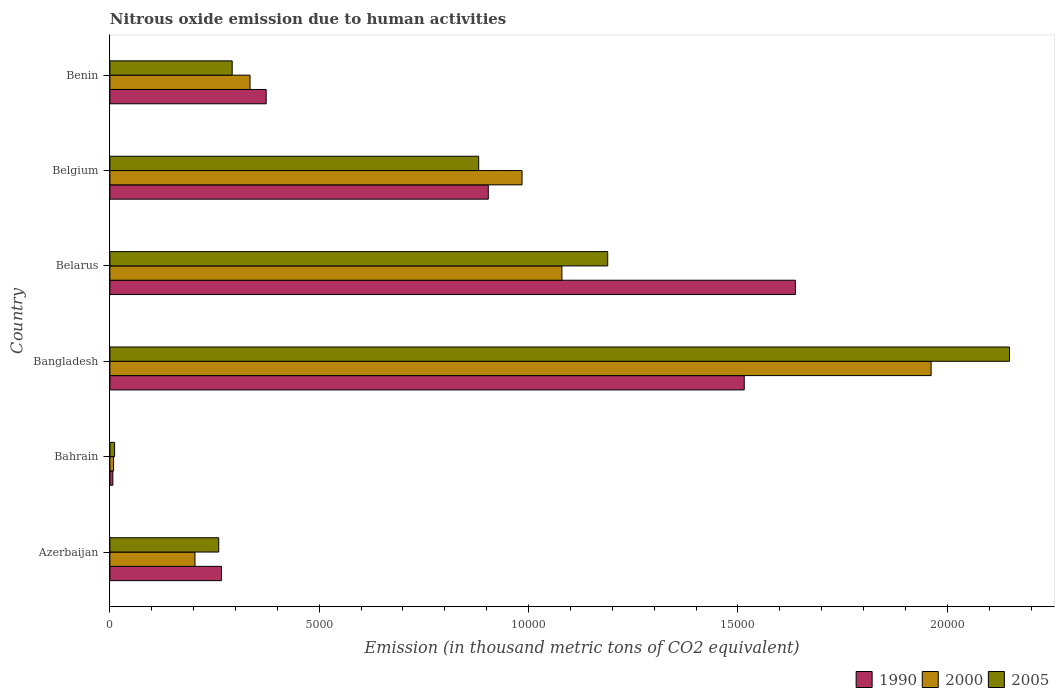How many groups of bars are there?
Offer a very short reply. 6. Are the number of bars per tick equal to the number of legend labels?
Your answer should be compact. Yes. What is the label of the 6th group of bars from the top?
Offer a terse response. Azerbaijan. What is the amount of nitrous oxide emitted in 2005 in Azerbaijan?
Make the answer very short. 2599.6. Across all countries, what is the maximum amount of nitrous oxide emitted in 2005?
Your response must be concise. 2.15e+04. Across all countries, what is the minimum amount of nitrous oxide emitted in 2005?
Provide a short and direct response. 112.9. In which country was the amount of nitrous oxide emitted in 2000 maximum?
Ensure brevity in your answer.  Bangladesh. In which country was the amount of nitrous oxide emitted in 2005 minimum?
Your answer should be compact. Bahrain. What is the total amount of nitrous oxide emitted in 2005 in the graph?
Provide a short and direct response. 4.78e+04. What is the difference between the amount of nitrous oxide emitted in 2005 in Bangladesh and that in Belgium?
Ensure brevity in your answer.  1.27e+04. What is the difference between the amount of nitrous oxide emitted in 2000 in Belarus and the amount of nitrous oxide emitted in 1990 in Azerbaijan?
Offer a terse response. 8130.1. What is the average amount of nitrous oxide emitted in 2000 per country?
Give a very brief answer. 7620.22. In how many countries, is the amount of nitrous oxide emitted in 1990 greater than 5000 thousand metric tons?
Your answer should be very brief. 3. What is the ratio of the amount of nitrous oxide emitted in 2005 in Bahrain to that in Bangladesh?
Provide a succinct answer. 0.01. Is the difference between the amount of nitrous oxide emitted in 2000 in Belarus and Belgium greater than the difference between the amount of nitrous oxide emitted in 1990 in Belarus and Belgium?
Offer a very short reply. No. What is the difference between the highest and the second highest amount of nitrous oxide emitted in 2000?
Provide a succinct answer. 8818.3. What is the difference between the highest and the lowest amount of nitrous oxide emitted in 1990?
Offer a terse response. 1.63e+04. In how many countries, is the amount of nitrous oxide emitted in 2000 greater than the average amount of nitrous oxide emitted in 2000 taken over all countries?
Provide a short and direct response. 3. How many bars are there?
Your answer should be very brief. 18. Are all the bars in the graph horizontal?
Ensure brevity in your answer.  Yes. Are the values on the major ticks of X-axis written in scientific E-notation?
Provide a succinct answer. No. Does the graph contain grids?
Give a very brief answer. No. How are the legend labels stacked?
Offer a very short reply. Horizontal. What is the title of the graph?
Offer a terse response. Nitrous oxide emission due to human activities. What is the label or title of the X-axis?
Offer a terse response. Emission (in thousand metric tons of CO2 equivalent). What is the Emission (in thousand metric tons of CO2 equivalent) in 1990 in Azerbaijan?
Offer a terse response. 2665.8. What is the Emission (in thousand metric tons of CO2 equivalent) in 2000 in Azerbaijan?
Your answer should be compact. 2031.7. What is the Emission (in thousand metric tons of CO2 equivalent) in 2005 in Azerbaijan?
Provide a succinct answer. 2599.6. What is the Emission (in thousand metric tons of CO2 equivalent) in 1990 in Bahrain?
Your answer should be very brief. 70.2. What is the Emission (in thousand metric tons of CO2 equivalent) in 2000 in Bahrain?
Your answer should be compact. 88.2. What is the Emission (in thousand metric tons of CO2 equivalent) in 2005 in Bahrain?
Ensure brevity in your answer.  112.9. What is the Emission (in thousand metric tons of CO2 equivalent) in 1990 in Bangladesh?
Give a very brief answer. 1.52e+04. What is the Emission (in thousand metric tons of CO2 equivalent) in 2000 in Bangladesh?
Your response must be concise. 1.96e+04. What is the Emission (in thousand metric tons of CO2 equivalent) of 2005 in Bangladesh?
Give a very brief answer. 2.15e+04. What is the Emission (in thousand metric tons of CO2 equivalent) of 1990 in Belarus?
Provide a short and direct response. 1.64e+04. What is the Emission (in thousand metric tons of CO2 equivalent) in 2000 in Belarus?
Provide a succinct answer. 1.08e+04. What is the Emission (in thousand metric tons of CO2 equivalent) in 2005 in Belarus?
Your answer should be very brief. 1.19e+04. What is the Emission (in thousand metric tons of CO2 equivalent) in 1990 in Belgium?
Your answer should be very brief. 9037.7. What is the Emission (in thousand metric tons of CO2 equivalent) in 2000 in Belgium?
Your answer should be very brief. 9844.1. What is the Emission (in thousand metric tons of CO2 equivalent) in 2005 in Belgium?
Your answer should be very brief. 8808.6. What is the Emission (in thousand metric tons of CO2 equivalent) of 1990 in Benin?
Your response must be concise. 3732.5. What is the Emission (in thousand metric tons of CO2 equivalent) in 2000 in Benin?
Offer a terse response. 3347.2. What is the Emission (in thousand metric tons of CO2 equivalent) in 2005 in Benin?
Provide a succinct answer. 2920.4. Across all countries, what is the maximum Emission (in thousand metric tons of CO2 equivalent) of 1990?
Keep it short and to the point. 1.64e+04. Across all countries, what is the maximum Emission (in thousand metric tons of CO2 equivalent) in 2000?
Make the answer very short. 1.96e+04. Across all countries, what is the maximum Emission (in thousand metric tons of CO2 equivalent) of 2005?
Offer a very short reply. 2.15e+04. Across all countries, what is the minimum Emission (in thousand metric tons of CO2 equivalent) of 1990?
Your answer should be compact. 70.2. Across all countries, what is the minimum Emission (in thousand metric tons of CO2 equivalent) of 2000?
Ensure brevity in your answer.  88.2. Across all countries, what is the minimum Emission (in thousand metric tons of CO2 equivalent) of 2005?
Your answer should be compact. 112.9. What is the total Emission (in thousand metric tons of CO2 equivalent) in 1990 in the graph?
Provide a succinct answer. 4.70e+04. What is the total Emission (in thousand metric tons of CO2 equivalent) in 2000 in the graph?
Your response must be concise. 4.57e+04. What is the total Emission (in thousand metric tons of CO2 equivalent) of 2005 in the graph?
Provide a succinct answer. 4.78e+04. What is the difference between the Emission (in thousand metric tons of CO2 equivalent) of 1990 in Azerbaijan and that in Bahrain?
Offer a very short reply. 2595.6. What is the difference between the Emission (in thousand metric tons of CO2 equivalent) of 2000 in Azerbaijan and that in Bahrain?
Keep it short and to the point. 1943.5. What is the difference between the Emission (in thousand metric tons of CO2 equivalent) in 2005 in Azerbaijan and that in Bahrain?
Ensure brevity in your answer.  2486.7. What is the difference between the Emission (in thousand metric tons of CO2 equivalent) of 1990 in Azerbaijan and that in Bangladesh?
Provide a short and direct response. -1.25e+04. What is the difference between the Emission (in thousand metric tons of CO2 equivalent) in 2000 in Azerbaijan and that in Bangladesh?
Make the answer very short. -1.76e+04. What is the difference between the Emission (in thousand metric tons of CO2 equivalent) of 2005 in Azerbaijan and that in Bangladesh?
Keep it short and to the point. -1.89e+04. What is the difference between the Emission (in thousand metric tons of CO2 equivalent) in 1990 in Azerbaijan and that in Belarus?
Provide a succinct answer. -1.37e+04. What is the difference between the Emission (in thousand metric tons of CO2 equivalent) of 2000 in Azerbaijan and that in Belarus?
Make the answer very short. -8764.2. What is the difference between the Emission (in thousand metric tons of CO2 equivalent) in 2005 in Azerbaijan and that in Belarus?
Offer a terse response. -9290.6. What is the difference between the Emission (in thousand metric tons of CO2 equivalent) in 1990 in Azerbaijan and that in Belgium?
Offer a very short reply. -6371.9. What is the difference between the Emission (in thousand metric tons of CO2 equivalent) of 2000 in Azerbaijan and that in Belgium?
Keep it short and to the point. -7812.4. What is the difference between the Emission (in thousand metric tons of CO2 equivalent) in 2005 in Azerbaijan and that in Belgium?
Your response must be concise. -6209. What is the difference between the Emission (in thousand metric tons of CO2 equivalent) in 1990 in Azerbaijan and that in Benin?
Make the answer very short. -1066.7. What is the difference between the Emission (in thousand metric tons of CO2 equivalent) in 2000 in Azerbaijan and that in Benin?
Ensure brevity in your answer.  -1315.5. What is the difference between the Emission (in thousand metric tons of CO2 equivalent) in 2005 in Azerbaijan and that in Benin?
Ensure brevity in your answer.  -320.8. What is the difference between the Emission (in thousand metric tons of CO2 equivalent) of 1990 in Bahrain and that in Bangladesh?
Give a very brief answer. -1.51e+04. What is the difference between the Emission (in thousand metric tons of CO2 equivalent) in 2000 in Bahrain and that in Bangladesh?
Give a very brief answer. -1.95e+04. What is the difference between the Emission (in thousand metric tons of CO2 equivalent) in 2005 in Bahrain and that in Bangladesh?
Make the answer very short. -2.14e+04. What is the difference between the Emission (in thousand metric tons of CO2 equivalent) of 1990 in Bahrain and that in Belarus?
Keep it short and to the point. -1.63e+04. What is the difference between the Emission (in thousand metric tons of CO2 equivalent) of 2000 in Bahrain and that in Belarus?
Your response must be concise. -1.07e+04. What is the difference between the Emission (in thousand metric tons of CO2 equivalent) of 2005 in Bahrain and that in Belarus?
Keep it short and to the point. -1.18e+04. What is the difference between the Emission (in thousand metric tons of CO2 equivalent) in 1990 in Bahrain and that in Belgium?
Your answer should be compact. -8967.5. What is the difference between the Emission (in thousand metric tons of CO2 equivalent) of 2000 in Bahrain and that in Belgium?
Offer a terse response. -9755.9. What is the difference between the Emission (in thousand metric tons of CO2 equivalent) in 2005 in Bahrain and that in Belgium?
Your answer should be compact. -8695.7. What is the difference between the Emission (in thousand metric tons of CO2 equivalent) in 1990 in Bahrain and that in Benin?
Make the answer very short. -3662.3. What is the difference between the Emission (in thousand metric tons of CO2 equivalent) in 2000 in Bahrain and that in Benin?
Offer a very short reply. -3259. What is the difference between the Emission (in thousand metric tons of CO2 equivalent) in 2005 in Bahrain and that in Benin?
Your answer should be very brief. -2807.5. What is the difference between the Emission (in thousand metric tons of CO2 equivalent) in 1990 in Bangladesh and that in Belarus?
Give a very brief answer. -1221.7. What is the difference between the Emission (in thousand metric tons of CO2 equivalent) of 2000 in Bangladesh and that in Belarus?
Give a very brief answer. 8818.3. What is the difference between the Emission (in thousand metric tons of CO2 equivalent) of 2005 in Bangladesh and that in Belarus?
Provide a succinct answer. 9596.5. What is the difference between the Emission (in thousand metric tons of CO2 equivalent) of 1990 in Bangladesh and that in Belgium?
Keep it short and to the point. 6112.9. What is the difference between the Emission (in thousand metric tons of CO2 equivalent) of 2000 in Bangladesh and that in Belgium?
Offer a terse response. 9770.1. What is the difference between the Emission (in thousand metric tons of CO2 equivalent) in 2005 in Bangladesh and that in Belgium?
Your response must be concise. 1.27e+04. What is the difference between the Emission (in thousand metric tons of CO2 equivalent) in 1990 in Bangladesh and that in Benin?
Your answer should be compact. 1.14e+04. What is the difference between the Emission (in thousand metric tons of CO2 equivalent) in 2000 in Bangladesh and that in Benin?
Provide a succinct answer. 1.63e+04. What is the difference between the Emission (in thousand metric tons of CO2 equivalent) in 2005 in Bangladesh and that in Benin?
Give a very brief answer. 1.86e+04. What is the difference between the Emission (in thousand metric tons of CO2 equivalent) of 1990 in Belarus and that in Belgium?
Ensure brevity in your answer.  7334.6. What is the difference between the Emission (in thousand metric tons of CO2 equivalent) of 2000 in Belarus and that in Belgium?
Ensure brevity in your answer.  951.8. What is the difference between the Emission (in thousand metric tons of CO2 equivalent) in 2005 in Belarus and that in Belgium?
Make the answer very short. 3081.6. What is the difference between the Emission (in thousand metric tons of CO2 equivalent) of 1990 in Belarus and that in Benin?
Offer a terse response. 1.26e+04. What is the difference between the Emission (in thousand metric tons of CO2 equivalent) in 2000 in Belarus and that in Benin?
Make the answer very short. 7448.7. What is the difference between the Emission (in thousand metric tons of CO2 equivalent) of 2005 in Belarus and that in Benin?
Keep it short and to the point. 8969.8. What is the difference between the Emission (in thousand metric tons of CO2 equivalent) in 1990 in Belgium and that in Benin?
Give a very brief answer. 5305.2. What is the difference between the Emission (in thousand metric tons of CO2 equivalent) of 2000 in Belgium and that in Benin?
Keep it short and to the point. 6496.9. What is the difference between the Emission (in thousand metric tons of CO2 equivalent) in 2005 in Belgium and that in Benin?
Ensure brevity in your answer.  5888.2. What is the difference between the Emission (in thousand metric tons of CO2 equivalent) of 1990 in Azerbaijan and the Emission (in thousand metric tons of CO2 equivalent) of 2000 in Bahrain?
Offer a terse response. 2577.6. What is the difference between the Emission (in thousand metric tons of CO2 equivalent) of 1990 in Azerbaijan and the Emission (in thousand metric tons of CO2 equivalent) of 2005 in Bahrain?
Your answer should be very brief. 2552.9. What is the difference between the Emission (in thousand metric tons of CO2 equivalent) in 2000 in Azerbaijan and the Emission (in thousand metric tons of CO2 equivalent) in 2005 in Bahrain?
Provide a short and direct response. 1918.8. What is the difference between the Emission (in thousand metric tons of CO2 equivalent) in 1990 in Azerbaijan and the Emission (in thousand metric tons of CO2 equivalent) in 2000 in Bangladesh?
Offer a terse response. -1.69e+04. What is the difference between the Emission (in thousand metric tons of CO2 equivalent) of 1990 in Azerbaijan and the Emission (in thousand metric tons of CO2 equivalent) of 2005 in Bangladesh?
Your response must be concise. -1.88e+04. What is the difference between the Emission (in thousand metric tons of CO2 equivalent) of 2000 in Azerbaijan and the Emission (in thousand metric tons of CO2 equivalent) of 2005 in Bangladesh?
Give a very brief answer. -1.95e+04. What is the difference between the Emission (in thousand metric tons of CO2 equivalent) in 1990 in Azerbaijan and the Emission (in thousand metric tons of CO2 equivalent) in 2000 in Belarus?
Provide a short and direct response. -8130.1. What is the difference between the Emission (in thousand metric tons of CO2 equivalent) of 1990 in Azerbaijan and the Emission (in thousand metric tons of CO2 equivalent) of 2005 in Belarus?
Your answer should be compact. -9224.4. What is the difference between the Emission (in thousand metric tons of CO2 equivalent) of 2000 in Azerbaijan and the Emission (in thousand metric tons of CO2 equivalent) of 2005 in Belarus?
Provide a short and direct response. -9858.5. What is the difference between the Emission (in thousand metric tons of CO2 equivalent) in 1990 in Azerbaijan and the Emission (in thousand metric tons of CO2 equivalent) in 2000 in Belgium?
Offer a very short reply. -7178.3. What is the difference between the Emission (in thousand metric tons of CO2 equivalent) in 1990 in Azerbaijan and the Emission (in thousand metric tons of CO2 equivalent) in 2005 in Belgium?
Your answer should be very brief. -6142.8. What is the difference between the Emission (in thousand metric tons of CO2 equivalent) of 2000 in Azerbaijan and the Emission (in thousand metric tons of CO2 equivalent) of 2005 in Belgium?
Ensure brevity in your answer.  -6776.9. What is the difference between the Emission (in thousand metric tons of CO2 equivalent) in 1990 in Azerbaijan and the Emission (in thousand metric tons of CO2 equivalent) in 2000 in Benin?
Your answer should be very brief. -681.4. What is the difference between the Emission (in thousand metric tons of CO2 equivalent) in 1990 in Azerbaijan and the Emission (in thousand metric tons of CO2 equivalent) in 2005 in Benin?
Provide a succinct answer. -254.6. What is the difference between the Emission (in thousand metric tons of CO2 equivalent) in 2000 in Azerbaijan and the Emission (in thousand metric tons of CO2 equivalent) in 2005 in Benin?
Provide a succinct answer. -888.7. What is the difference between the Emission (in thousand metric tons of CO2 equivalent) of 1990 in Bahrain and the Emission (in thousand metric tons of CO2 equivalent) of 2000 in Bangladesh?
Offer a terse response. -1.95e+04. What is the difference between the Emission (in thousand metric tons of CO2 equivalent) of 1990 in Bahrain and the Emission (in thousand metric tons of CO2 equivalent) of 2005 in Bangladesh?
Ensure brevity in your answer.  -2.14e+04. What is the difference between the Emission (in thousand metric tons of CO2 equivalent) in 2000 in Bahrain and the Emission (in thousand metric tons of CO2 equivalent) in 2005 in Bangladesh?
Offer a very short reply. -2.14e+04. What is the difference between the Emission (in thousand metric tons of CO2 equivalent) of 1990 in Bahrain and the Emission (in thousand metric tons of CO2 equivalent) of 2000 in Belarus?
Offer a terse response. -1.07e+04. What is the difference between the Emission (in thousand metric tons of CO2 equivalent) in 1990 in Bahrain and the Emission (in thousand metric tons of CO2 equivalent) in 2005 in Belarus?
Give a very brief answer. -1.18e+04. What is the difference between the Emission (in thousand metric tons of CO2 equivalent) of 2000 in Bahrain and the Emission (in thousand metric tons of CO2 equivalent) of 2005 in Belarus?
Make the answer very short. -1.18e+04. What is the difference between the Emission (in thousand metric tons of CO2 equivalent) of 1990 in Bahrain and the Emission (in thousand metric tons of CO2 equivalent) of 2000 in Belgium?
Your response must be concise. -9773.9. What is the difference between the Emission (in thousand metric tons of CO2 equivalent) in 1990 in Bahrain and the Emission (in thousand metric tons of CO2 equivalent) in 2005 in Belgium?
Ensure brevity in your answer.  -8738.4. What is the difference between the Emission (in thousand metric tons of CO2 equivalent) in 2000 in Bahrain and the Emission (in thousand metric tons of CO2 equivalent) in 2005 in Belgium?
Your answer should be very brief. -8720.4. What is the difference between the Emission (in thousand metric tons of CO2 equivalent) in 1990 in Bahrain and the Emission (in thousand metric tons of CO2 equivalent) in 2000 in Benin?
Make the answer very short. -3277. What is the difference between the Emission (in thousand metric tons of CO2 equivalent) in 1990 in Bahrain and the Emission (in thousand metric tons of CO2 equivalent) in 2005 in Benin?
Offer a very short reply. -2850.2. What is the difference between the Emission (in thousand metric tons of CO2 equivalent) of 2000 in Bahrain and the Emission (in thousand metric tons of CO2 equivalent) of 2005 in Benin?
Offer a very short reply. -2832.2. What is the difference between the Emission (in thousand metric tons of CO2 equivalent) in 1990 in Bangladesh and the Emission (in thousand metric tons of CO2 equivalent) in 2000 in Belarus?
Provide a short and direct response. 4354.7. What is the difference between the Emission (in thousand metric tons of CO2 equivalent) in 1990 in Bangladesh and the Emission (in thousand metric tons of CO2 equivalent) in 2005 in Belarus?
Your answer should be compact. 3260.4. What is the difference between the Emission (in thousand metric tons of CO2 equivalent) of 2000 in Bangladesh and the Emission (in thousand metric tons of CO2 equivalent) of 2005 in Belarus?
Offer a terse response. 7724. What is the difference between the Emission (in thousand metric tons of CO2 equivalent) in 1990 in Bangladesh and the Emission (in thousand metric tons of CO2 equivalent) in 2000 in Belgium?
Your answer should be compact. 5306.5. What is the difference between the Emission (in thousand metric tons of CO2 equivalent) of 1990 in Bangladesh and the Emission (in thousand metric tons of CO2 equivalent) of 2005 in Belgium?
Make the answer very short. 6342. What is the difference between the Emission (in thousand metric tons of CO2 equivalent) in 2000 in Bangladesh and the Emission (in thousand metric tons of CO2 equivalent) in 2005 in Belgium?
Keep it short and to the point. 1.08e+04. What is the difference between the Emission (in thousand metric tons of CO2 equivalent) of 1990 in Bangladesh and the Emission (in thousand metric tons of CO2 equivalent) of 2000 in Benin?
Your response must be concise. 1.18e+04. What is the difference between the Emission (in thousand metric tons of CO2 equivalent) of 1990 in Bangladesh and the Emission (in thousand metric tons of CO2 equivalent) of 2005 in Benin?
Offer a terse response. 1.22e+04. What is the difference between the Emission (in thousand metric tons of CO2 equivalent) in 2000 in Bangladesh and the Emission (in thousand metric tons of CO2 equivalent) in 2005 in Benin?
Make the answer very short. 1.67e+04. What is the difference between the Emission (in thousand metric tons of CO2 equivalent) of 1990 in Belarus and the Emission (in thousand metric tons of CO2 equivalent) of 2000 in Belgium?
Ensure brevity in your answer.  6528.2. What is the difference between the Emission (in thousand metric tons of CO2 equivalent) in 1990 in Belarus and the Emission (in thousand metric tons of CO2 equivalent) in 2005 in Belgium?
Keep it short and to the point. 7563.7. What is the difference between the Emission (in thousand metric tons of CO2 equivalent) in 2000 in Belarus and the Emission (in thousand metric tons of CO2 equivalent) in 2005 in Belgium?
Your answer should be compact. 1987.3. What is the difference between the Emission (in thousand metric tons of CO2 equivalent) in 1990 in Belarus and the Emission (in thousand metric tons of CO2 equivalent) in 2000 in Benin?
Provide a succinct answer. 1.30e+04. What is the difference between the Emission (in thousand metric tons of CO2 equivalent) in 1990 in Belarus and the Emission (in thousand metric tons of CO2 equivalent) in 2005 in Benin?
Provide a succinct answer. 1.35e+04. What is the difference between the Emission (in thousand metric tons of CO2 equivalent) in 2000 in Belarus and the Emission (in thousand metric tons of CO2 equivalent) in 2005 in Benin?
Make the answer very short. 7875.5. What is the difference between the Emission (in thousand metric tons of CO2 equivalent) in 1990 in Belgium and the Emission (in thousand metric tons of CO2 equivalent) in 2000 in Benin?
Offer a very short reply. 5690.5. What is the difference between the Emission (in thousand metric tons of CO2 equivalent) of 1990 in Belgium and the Emission (in thousand metric tons of CO2 equivalent) of 2005 in Benin?
Provide a short and direct response. 6117.3. What is the difference between the Emission (in thousand metric tons of CO2 equivalent) of 2000 in Belgium and the Emission (in thousand metric tons of CO2 equivalent) of 2005 in Benin?
Keep it short and to the point. 6923.7. What is the average Emission (in thousand metric tons of CO2 equivalent) of 1990 per country?
Offer a very short reply. 7838.18. What is the average Emission (in thousand metric tons of CO2 equivalent) of 2000 per country?
Keep it short and to the point. 7620.22. What is the average Emission (in thousand metric tons of CO2 equivalent) of 2005 per country?
Provide a short and direct response. 7969.73. What is the difference between the Emission (in thousand metric tons of CO2 equivalent) in 1990 and Emission (in thousand metric tons of CO2 equivalent) in 2000 in Azerbaijan?
Offer a very short reply. 634.1. What is the difference between the Emission (in thousand metric tons of CO2 equivalent) of 1990 and Emission (in thousand metric tons of CO2 equivalent) of 2005 in Azerbaijan?
Your answer should be compact. 66.2. What is the difference between the Emission (in thousand metric tons of CO2 equivalent) in 2000 and Emission (in thousand metric tons of CO2 equivalent) in 2005 in Azerbaijan?
Offer a very short reply. -567.9. What is the difference between the Emission (in thousand metric tons of CO2 equivalent) of 1990 and Emission (in thousand metric tons of CO2 equivalent) of 2005 in Bahrain?
Offer a very short reply. -42.7. What is the difference between the Emission (in thousand metric tons of CO2 equivalent) of 2000 and Emission (in thousand metric tons of CO2 equivalent) of 2005 in Bahrain?
Your answer should be very brief. -24.7. What is the difference between the Emission (in thousand metric tons of CO2 equivalent) of 1990 and Emission (in thousand metric tons of CO2 equivalent) of 2000 in Bangladesh?
Make the answer very short. -4463.6. What is the difference between the Emission (in thousand metric tons of CO2 equivalent) of 1990 and Emission (in thousand metric tons of CO2 equivalent) of 2005 in Bangladesh?
Your answer should be compact. -6336.1. What is the difference between the Emission (in thousand metric tons of CO2 equivalent) of 2000 and Emission (in thousand metric tons of CO2 equivalent) of 2005 in Bangladesh?
Keep it short and to the point. -1872.5. What is the difference between the Emission (in thousand metric tons of CO2 equivalent) in 1990 and Emission (in thousand metric tons of CO2 equivalent) in 2000 in Belarus?
Ensure brevity in your answer.  5576.4. What is the difference between the Emission (in thousand metric tons of CO2 equivalent) in 1990 and Emission (in thousand metric tons of CO2 equivalent) in 2005 in Belarus?
Your answer should be compact. 4482.1. What is the difference between the Emission (in thousand metric tons of CO2 equivalent) in 2000 and Emission (in thousand metric tons of CO2 equivalent) in 2005 in Belarus?
Keep it short and to the point. -1094.3. What is the difference between the Emission (in thousand metric tons of CO2 equivalent) of 1990 and Emission (in thousand metric tons of CO2 equivalent) of 2000 in Belgium?
Make the answer very short. -806.4. What is the difference between the Emission (in thousand metric tons of CO2 equivalent) of 1990 and Emission (in thousand metric tons of CO2 equivalent) of 2005 in Belgium?
Ensure brevity in your answer.  229.1. What is the difference between the Emission (in thousand metric tons of CO2 equivalent) of 2000 and Emission (in thousand metric tons of CO2 equivalent) of 2005 in Belgium?
Your answer should be compact. 1035.5. What is the difference between the Emission (in thousand metric tons of CO2 equivalent) of 1990 and Emission (in thousand metric tons of CO2 equivalent) of 2000 in Benin?
Your answer should be compact. 385.3. What is the difference between the Emission (in thousand metric tons of CO2 equivalent) in 1990 and Emission (in thousand metric tons of CO2 equivalent) in 2005 in Benin?
Give a very brief answer. 812.1. What is the difference between the Emission (in thousand metric tons of CO2 equivalent) of 2000 and Emission (in thousand metric tons of CO2 equivalent) of 2005 in Benin?
Your answer should be compact. 426.8. What is the ratio of the Emission (in thousand metric tons of CO2 equivalent) of 1990 in Azerbaijan to that in Bahrain?
Make the answer very short. 37.97. What is the ratio of the Emission (in thousand metric tons of CO2 equivalent) in 2000 in Azerbaijan to that in Bahrain?
Your response must be concise. 23.04. What is the ratio of the Emission (in thousand metric tons of CO2 equivalent) in 2005 in Azerbaijan to that in Bahrain?
Provide a short and direct response. 23.03. What is the ratio of the Emission (in thousand metric tons of CO2 equivalent) of 1990 in Azerbaijan to that in Bangladesh?
Provide a succinct answer. 0.18. What is the ratio of the Emission (in thousand metric tons of CO2 equivalent) in 2000 in Azerbaijan to that in Bangladesh?
Keep it short and to the point. 0.1. What is the ratio of the Emission (in thousand metric tons of CO2 equivalent) in 2005 in Azerbaijan to that in Bangladesh?
Provide a succinct answer. 0.12. What is the ratio of the Emission (in thousand metric tons of CO2 equivalent) of 1990 in Azerbaijan to that in Belarus?
Your answer should be very brief. 0.16. What is the ratio of the Emission (in thousand metric tons of CO2 equivalent) of 2000 in Azerbaijan to that in Belarus?
Make the answer very short. 0.19. What is the ratio of the Emission (in thousand metric tons of CO2 equivalent) of 2005 in Azerbaijan to that in Belarus?
Ensure brevity in your answer.  0.22. What is the ratio of the Emission (in thousand metric tons of CO2 equivalent) in 1990 in Azerbaijan to that in Belgium?
Keep it short and to the point. 0.29. What is the ratio of the Emission (in thousand metric tons of CO2 equivalent) in 2000 in Azerbaijan to that in Belgium?
Give a very brief answer. 0.21. What is the ratio of the Emission (in thousand metric tons of CO2 equivalent) in 2005 in Azerbaijan to that in Belgium?
Provide a succinct answer. 0.3. What is the ratio of the Emission (in thousand metric tons of CO2 equivalent) in 1990 in Azerbaijan to that in Benin?
Offer a terse response. 0.71. What is the ratio of the Emission (in thousand metric tons of CO2 equivalent) of 2000 in Azerbaijan to that in Benin?
Your answer should be compact. 0.61. What is the ratio of the Emission (in thousand metric tons of CO2 equivalent) of 2005 in Azerbaijan to that in Benin?
Make the answer very short. 0.89. What is the ratio of the Emission (in thousand metric tons of CO2 equivalent) in 1990 in Bahrain to that in Bangladesh?
Your answer should be compact. 0. What is the ratio of the Emission (in thousand metric tons of CO2 equivalent) in 2000 in Bahrain to that in Bangladesh?
Keep it short and to the point. 0. What is the ratio of the Emission (in thousand metric tons of CO2 equivalent) in 2005 in Bahrain to that in Bangladesh?
Provide a succinct answer. 0.01. What is the ratio of the Emission (in thousand metric tons of CO2 equivalent) of 1990 in Bahrain to that in Belarus?
Provide a short and direct response. 0. What is the ratio of the Emission (in thousand metric tons of CO2 equivalent) in 2000 in Bahrain to that in Belarus?
Ensure brevity in your answer.  0.01. What is the ratio of the Emission (in thousand metric tons of CO2 equivalent) of 2005 in Bahrain to that in Belarus?
Offer a very short reply. 0.01. What is the ratio of the Emission (in thousand metric tons of CO2 equivalent) in 1990 in Bahrain to that in Belgium?
Make the answer very short. 0.01. What is the ratio of the Emission (in thousand metric tons of CO2 equivalent) in 2000 in Bahrain to that in Belgium?
Make the answer very short. 0.01. What is the ratio of the Emission (in thousand metric tons of CO2 equivalent) of 2005 in Bahrain to that in Belgium?
Provide a short and direct response. 0.01. What is the ratio of the Emission (in thousand metric tons of CO2 equivalent) of 1990 in Bahrain to that in Benin?
Ensure brevity in your answer.  0.02. What is the ratio of the Emission (in thousand metric tons of CO2 equivalent) of 2000 in Bahrain to that in Benin?
Offer a very short reply. 0.03. What is the ratio of the Emission (in thousand metric tons of CO2 equivalent) in 2005 in Bahrain to that in Benin?
Offer a very short reply. 0.04. What is the ratio of the Emission (in thousand metric tons of CO2 equivalent) of 1990 in Bangladesh to that in Belarus?
Your answer should be very brief. 0.93. What is the ratio of the Emission (in thousand metric tons of CO2 equivalent) in 2000 in Bangladesh to that in Belarus?
Offer a terse response. 1.82. What is the ratio of the Emission (in thousand metric tons of CO2 equivalent) of 2005 in Bangladesh to that in Belarus?
Give a very brief answer. 1.81. What is the ratio of the Emission (in thousand metric tons of CO2 equivalent) of 1990 in Bangladesh to that in Belgium?
Ensure brevity in your answer.  1.68. What is the ratio of the Emission (in thousand metric tons of CO2 equivalent) in 2000 in Bangladesh to that in Belgium?
Your response must be concise. 1.99. What is the ratio of the Emission (in thousand metric tons of CO2 equivalent) in 2005 in Bangladesh to that in Belgium?
Offer a very short reply. 2.44. What is the ratio of the Emission (in thousand metric tons of CO2 equivalent) in 1990 in Bangladesh to that in Benin?
Provide a short and direct response. 4.06. What is the ratio of the Emission (in thousand metric tons of CO2 equivalent) of 2000 in Bangladesh to that in Benin?
Keep it short and to the point. 5.86. What is the ratio of the Emission (in thousand metric tons of CO2 equivalent) of 2005 in Bangladesh to that in Benin?
Your response must be concise. 7.36. What is the ratio of the Emission (in thousand metric tons of CO2 equivalent) in 1990 in Belarus to that in Belgium?
Make the answer very short. 1.81. What is the ratio of the Emission (in thousand metric tons of CO2 equivalent) of 2000 in Belarus to that in Belgium?
Your response must be concise. 1.1. What is the ratio of the Emission (in thousand metric tons of CO2 equivalent) in 2005 in Belarus to that in Belgium?
Make the answer very short. 1.35. What is the ratio of the Emission (in thousand metric tons of CO2 equivalent) in 1990 in Belarus to that in Benin?
Keep it short and to the point. 4.39. What is the ratio of the Emission (in thousand metric tons of CO2 equivalent) in 2000 in Belarus to that in Benin?
Provide a succinct answer. 3.23. What is the ratio of the Emission (in thousand metric tons of CO2 equivalent) in 2005 in Belarus to that in Benin?
Your answer should be compact. 4.07. What is the ratio of the Emission (in thousand metric tons of CO2 equivalent) of 1990 in Belgium to that in Benin?
Your response must be concise. 2.42. What is the ratio of the Emission (in thousand metric tons of CO2 equivalent) in 2000 in Belgium to that in Benin?
Your response must be concise. 2.94. What is the ratio of the Emission (in thousand metric tons of CO2 equivalent) in 2005 in Belgium to that in Benin?
Ensure brevity in your answer.  3.02. What is the difference between the highest and the second highest Emission (in thousand metric tons of CO2 equivalent) in 1990?
Offer a very short reply. 1221.7. What is the difference between the highest and the second highest Emission (in thousand metric tons of CO2 equivalent) of 2000?
Your response must be concise. 8818.3. What is the difference between the highest and the second highest Emission (in thousand metric tons of CO2 equivalent) of 2005?
Your answer should be compact. 9596.5. What is the difference between the highest and the lowest Emission (in thousand metric tons of CO2 equivalent) of 1990?
Offer a terse response. 1.63e+04. What is the difference between the highest and the lowest Emission (in thousand metric tons of CO2 equivalent) in 2000?
Keep it short and to the point. 1.95e+04. What is the difference between the highest and the lowest Emission (in thousand metric tons of CO2 equivalent) in 2005?
Provide a succinct answer. 2.14e+04. 